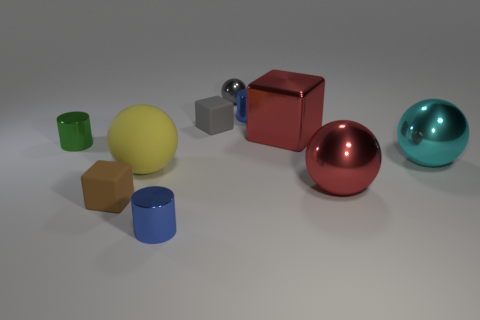What is the material of the tiny thing that is the same color as the tiny ball?
Ensure brevity in your answer.  Rubber. What is the shape of the large object that is both behind the red sphere and right of the big red block?
Your answer should be very brief. Sphere. What is the shape of the metallic thing behind the small blue shiny thing behind the gray object in front of the tiny gray metallic thing?
Keep it short and to the point. Sphere. There is a block that is in front of the tiny gray matte object and behind the small green metal cylinder; what is it made of?
Keep it short and to the point. Metal. What number of green objects are the same size as the gray matte block?
Your response must be concise. 1. How many shiny objects are either big red objects or tiny green objects?
Your response must be concise. 3. What material is the big red ball?
Provide a succinct answer. Metal. There is a tiny green metallic cylinder; how many small gray matte cubes are in front of it?
Ensure brevity in your answer.  0. Is the large object that is behind the cyan thing made of the same material as the green object?
Provide a succinct answer. Yes. How many other objects have the same shape as the green object?
Make the answer very short. 2. 